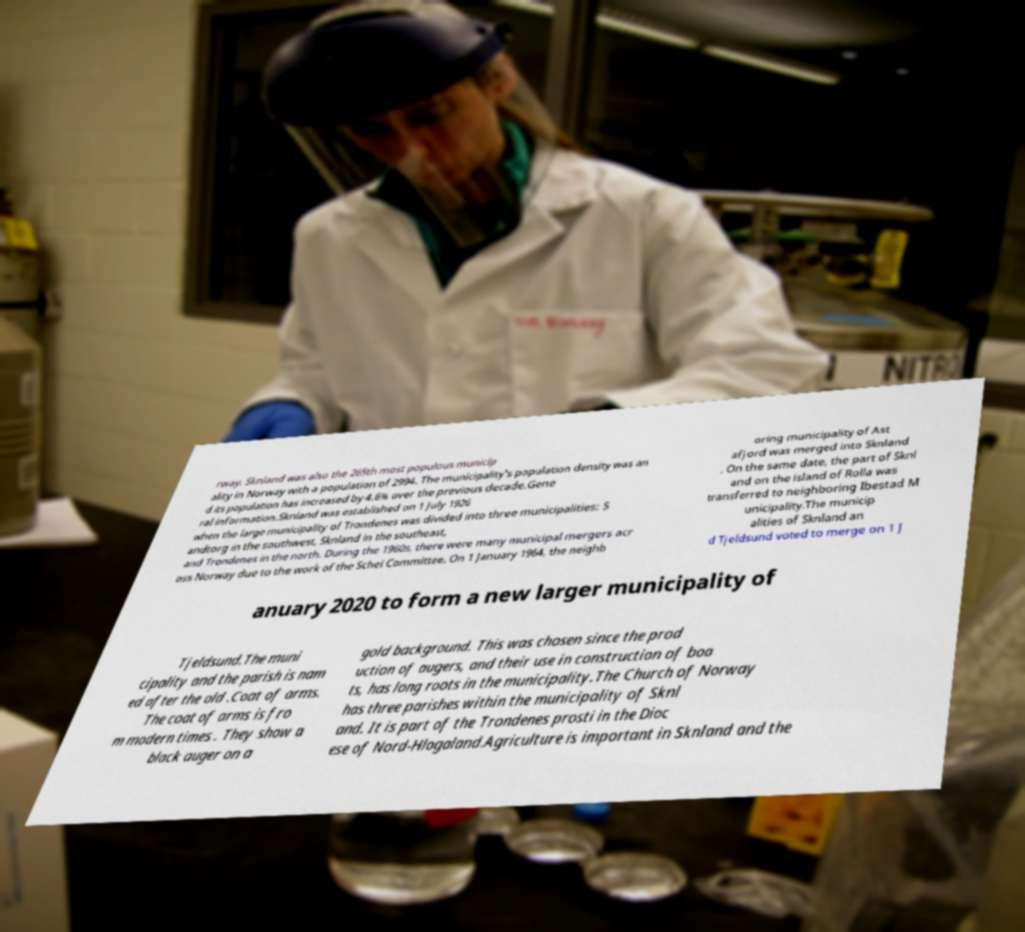Could you assist in decoding the text presented in this image and type it out clearly? rway. Sknland was also the 265th most populous municip ality in Norway with a population of 2994. The municipality's population density was an d its population has increased by 4.6% over the previous decade.Gene ral information.Sknland was established on 1 July 1926 when the large municipality of Trondenes was divided into three municipalities: S andtorg in the southwest, Sknland in the southeast, and Trondenes in the north. During the 1960s, there were many municipal mergers acr oss Norway due to the work of the Schei Committee. On 1 January 1964, the neighb oring municipality of Ast afjord was merged into Sknland . On the same date, the part of Sknl and on the island of Rolla was transferred to neighboring Ibestad M unicipality.The municip alities of Sknland an d Tjeldsund voted to merge on 1 J anuary 2020 to form a new larger municipality of Tjeldsund.The muni cipality and the parish is nam ed after the old .Coat of arms. The coat of arms is fro m modern times . They show a black auger on a gold background. This was chosen since the prod uction of augers, and their use in construction of boa ts, has long roots in the municipality.The Church of Norway has three parishes within the municipality of Sknl and. It is part of the Trondenes prosti in the Dioc ese of Nord-Hlogaland.Agriculture is important in Sknland and the 